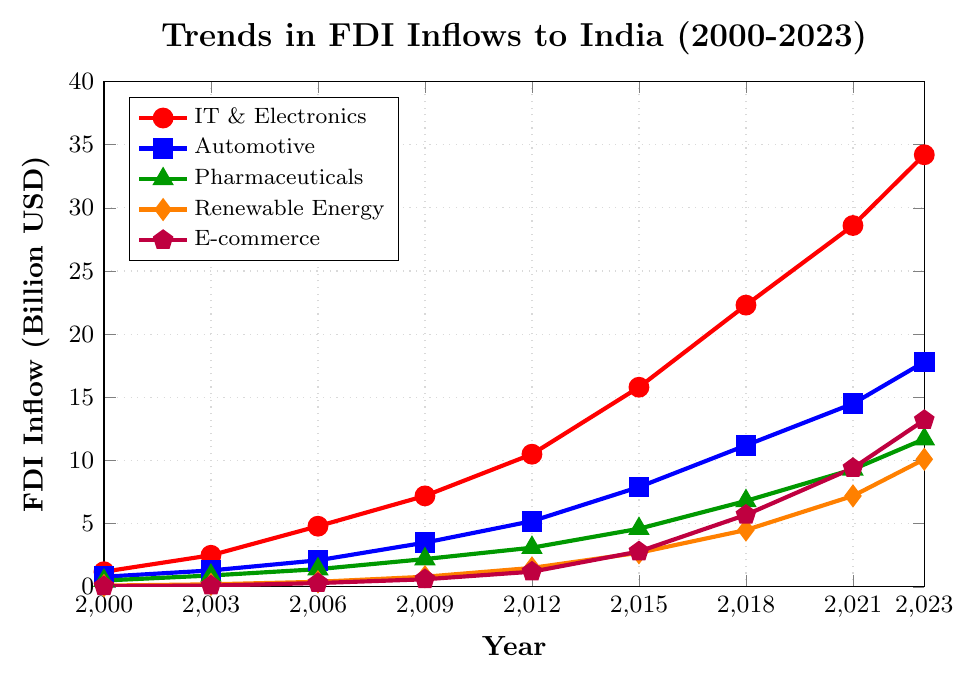Which industry had the highest FDI inflow in 2023? To find the industry with the highest FDI inflow in 2023, check the value at the endpoint (2023) of each line in the figure. The highest value is for the E-commerce industry.
Answer: E-commerce Which industry showed the most consistent growth in FDI inflows over the entire period (2000-2023)? Consistent growth can be seen as a steady increase in the plot line without sharp fluctuations. The IT & Electronics industry shows a steady upward trend without significant dips from 2000 to 2023.
Answer: IT & Electronics Between 2009 and 2023, which industry experienced the greatest increase in FDI inflows? To determine this, subtract the value in 2009 from the value in 2023 for each industry: IT & Electronics (34.2 - 7.2 = 27), Automotive (17.8 - 3.5 = 14.3), Pharmaceuticals (11.7 - 2.2 = 9.5), Renewable Energy (10.1 - 0.8 = 9.3), E-commerce (13.2 - 0.6 = 12.6). The IT & Electronics industry experienced the greatest increase.
Answer: IT & Electronics How much did the FDI inflows for E-commerce grow between 2015 and 2021? To find the growth, subtract the FDI inflow value for 2015 from that of 2021: 9.4 - 2.8 = 6.6 billion USD.
Answer: 6.6 billion USD In which year did the Renewable Energy industry first surpass 5 billion USD in FDI inflows? Check when the plot line for Renewable Energy first exceeds 5 billion USD. This occurs in 2018.
Answer: 2018 How did the FDI inflow in the Automotive industry change from 2003 to 2009? Subtract the 2003 value from the 2009 value for the Automotive industry: 3.5 - 1.3 = 2.2 billion USD. This indicates an increase of 2.2 billion USD.
Answer: Increased by 2.2 billion USD Compare the FDI inflows for IT & Electronics in 2000 and for Renewable Energy in 2023. Which is higher and by how much? Compare the two values: IT & Electronics in 2000 is 1.2 billion USD, while Renewable Energy in 2023 is 10.1 billion USD. Renewable Energy in 2023 is higher by 10.1 - 1.2 = 8.9 billion USD.
Answer: Renewable Energy by 8.9 billion USD What is the difference in FDI inflows between the Pharmaceuticals and E-commerce industries in 2023? Subtract the Pharmaceuticals value from the E-commerce value in 2023: 13.2 - 11.7 = 1.5 billion USD.
Answer: 1.5 billion USD In which year did the Automotive industry's FDI inflows first reach or exceed the 10 billion USD mark? Identify the first year when the Automotive industry’s line crosses the 10 billion USD mark, which is in 2018.
Answer: 2018 Which industry had the lowest FDI inflows in 2012, and what was the amount? Identify the industry with the lowest point on the plot for 2012. Renewable Energy has the lowest FDI inflow in 2012, which is 1.5 billion USD.
Answer: Renewable Energy, 1.5 billion USD 